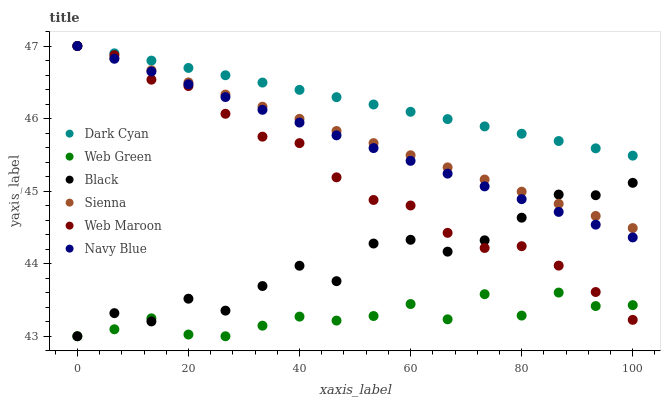Does Web Green have the minimum area under the curve?
Answer yes or no. Yes. Does Dark Cyan have the maximum area under the curve?
Answer yes or no. Yes. Does Web Maroon have the minimum area under the curve?
Answer yes or no. No. Does Web Maroon have the maximum area under the curve?
Answer yes or no. No. Is Sienna the smoothest?
Answer yes or no. Yes. Is Black the roughest?
Answer yes or no. Yes. Is Web Maroon the smoothest?
Answer yes or no. No. Is Web Maroon the roughest?
Answer yes or no. No. Does Web Green have the lowest value?
Answer yes or no. Yes. Does Web Maroon have the lowest value?
Answer yes or no. No. Does Dark Cyan have the highest value?
Answer yes or no. Yes. Does Web Green have the highest value?
Answer yes or no. No. Is Web Green less than Navy Blue?
Answer yes or no. Yes. Is Navy Blue greater than Web Green?
Answer yes or no. Yes. Does Navy Blue intersect Dark Cyan?
Answer yes or no. Yes. Is Navy Blue less than Dark Cyan?
Answer yes or no. No. Is Navy Blue greater than Dark Cyan?
Answer yes or no. No. Does Web Green intersect Navy Blue?
Answer yes or no. No. 